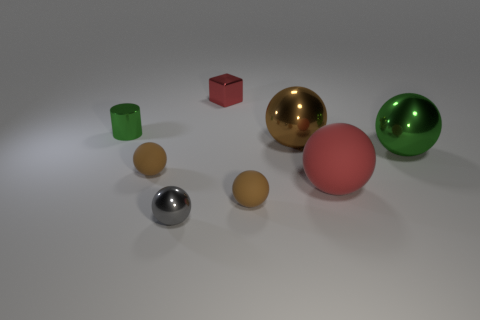How many brown balls must be subtracted to get 1 brown balls? 2 Subtract all tiny gray shiny balls. How many balls are left? 5 Subtract all green balls. How many balls are left? 5 Subtract 3 spheres. How many spheres are left? 3 Subtract all cyan cubes. How many brown spheres are left? 3 Subtract all spheres. How many objects are left? 2 Add 1 large brown metal cylinders. How many objects exist? 9 Add 8 large green metal things. How many large green metal things are left? 9 Add 4 metal cylinders. How many metal cylinders exist? 5 Subtract 0 purple blocks. How many objects are left? 8 